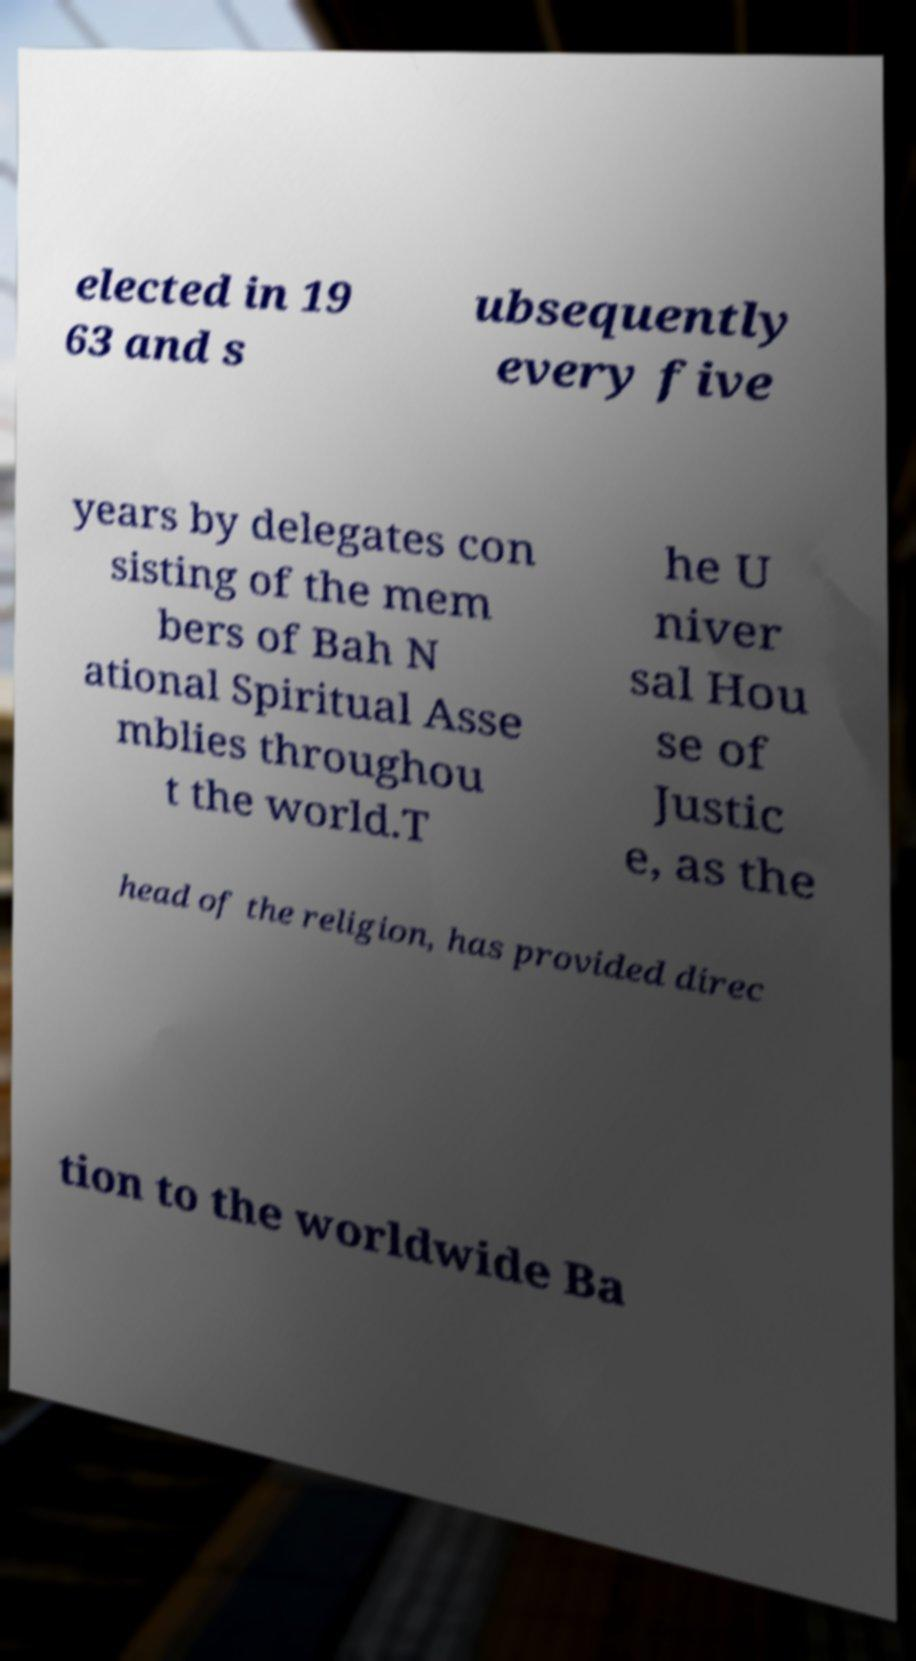Could you extract and type out the text from this image? elected in 19 63 and s ubsequently every five years by delegates con sisting of the mem bers of Bah N ational Spiritual Asse mblies throughou t the world.T he U niver sal Hou se of Justic e, as the head of the religion, has provided direc tion to the worldwide Ba 